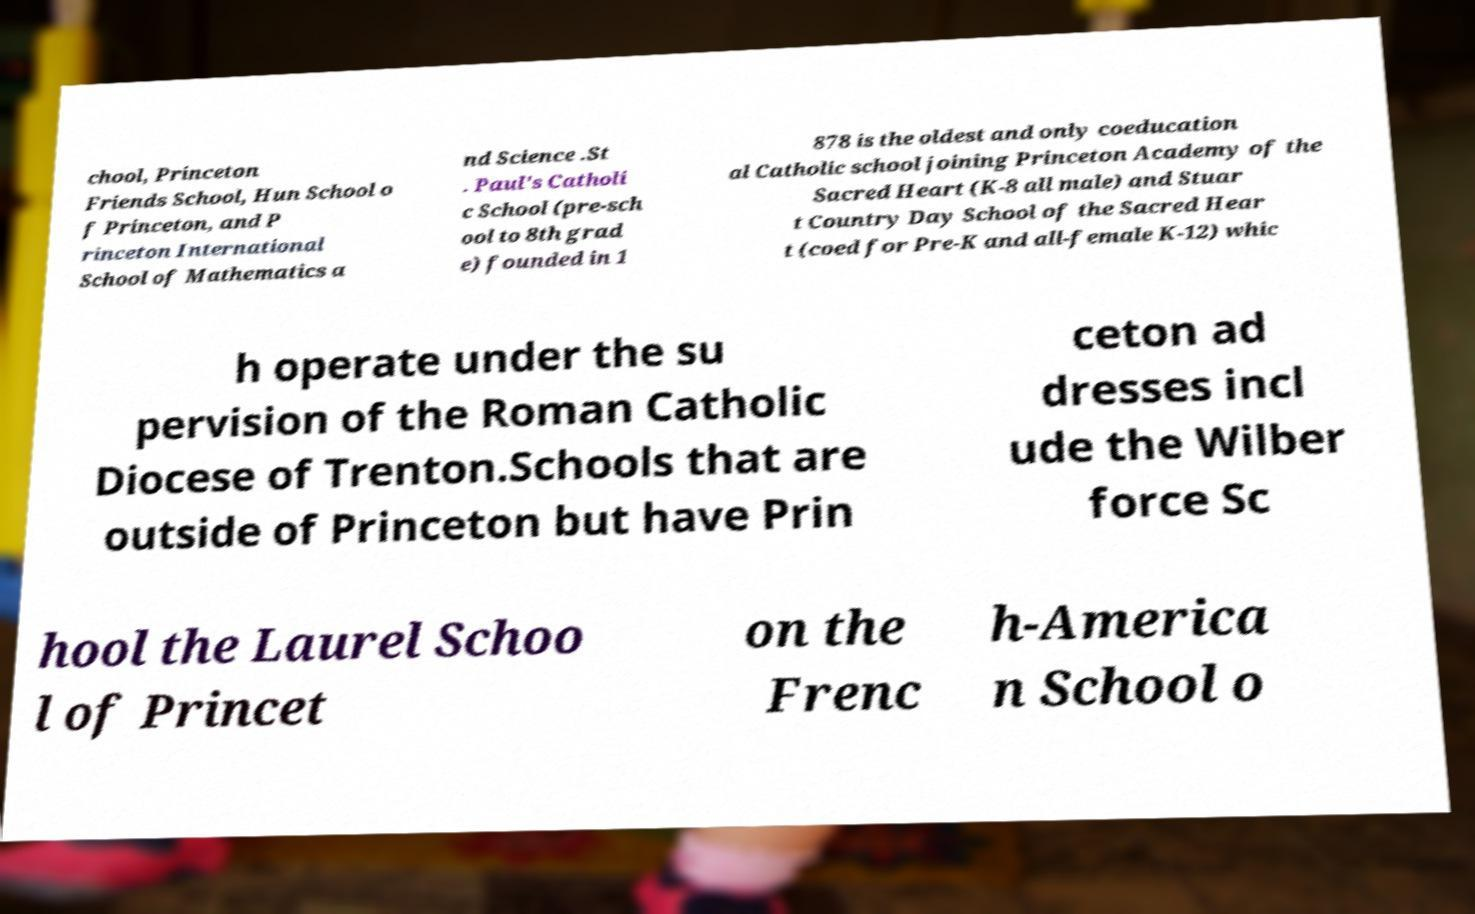Could you assist in decoding the text presented in this image and type it out clearly? chool, Princeton Friends School, Hun School o f Princeton, and P rinceton International School of Mathematics a nd Science .St . Paul's Catholi c School (pre-sch ool to 8th grad e) founded in 1 878 is the oldest and only coeducation al Catholic school joining Princeton Academy of the Sacred Heart (K-8 all male) and Stuar t Country Day School of the Sacred Hear t (coed for Pre-K and all-female K-12) whic h operate under the su pervision of the Roman Catholic Diocese of Trenton.Schools that are outside of Princeton but have Prin ceton ad dresses incl ude the Wilber force Sc hool the Laurel Schoo l of Princet on the Frenc h-America n School o 